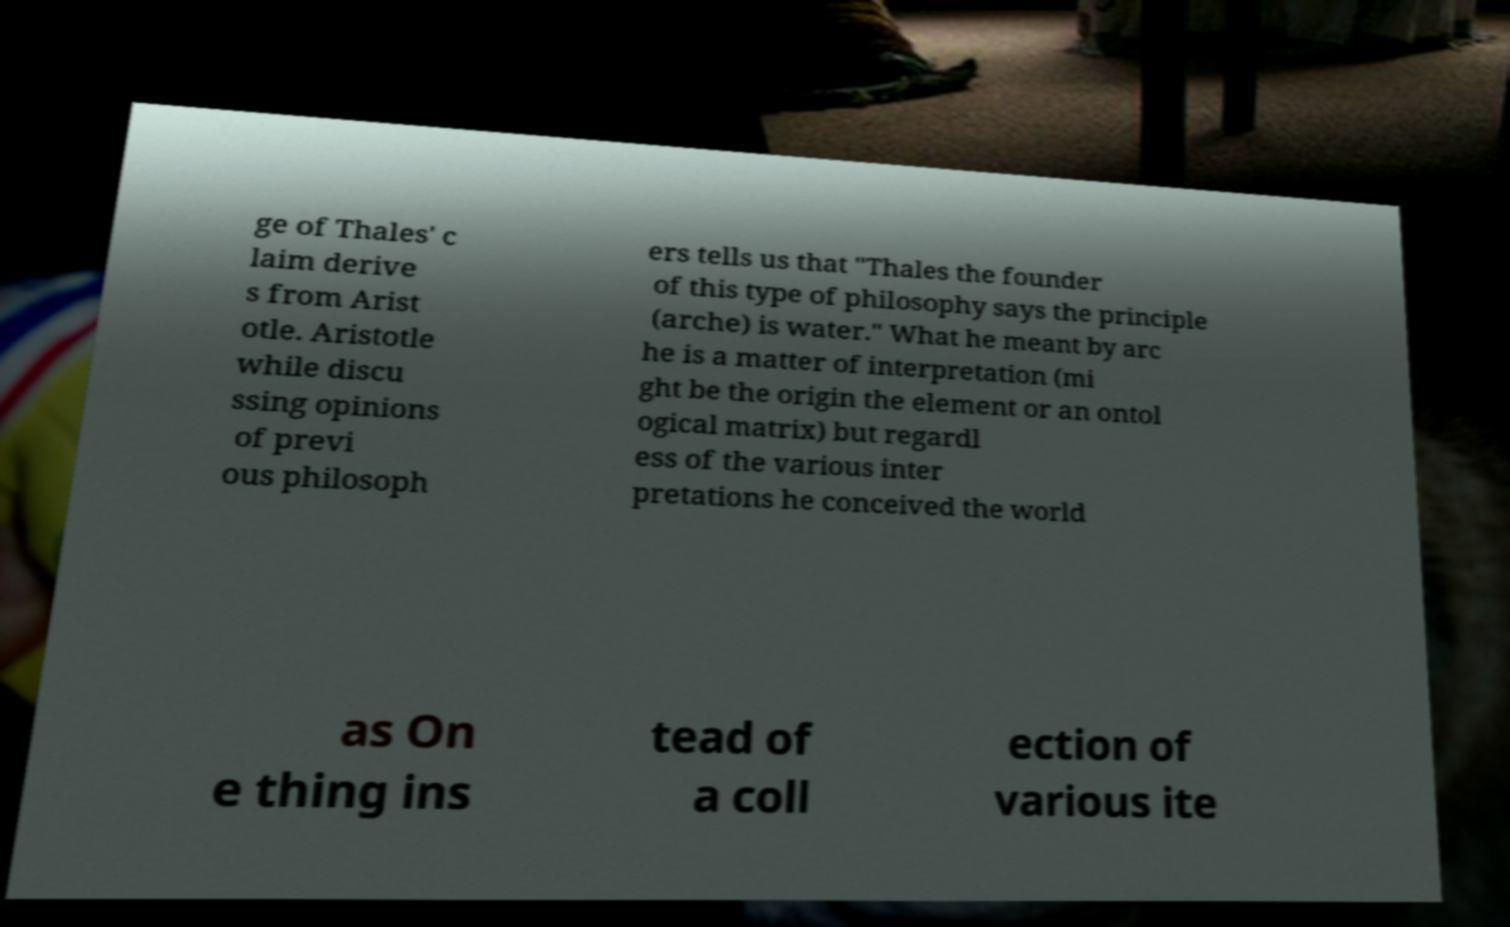I need the written content from this picture converted into text. Can you do that? ge of Thales' c laim derive s from Arist otle. Aristotle while discu ssing opinions of previ ous philosoph ers tells us that "Thales the founder of this type of philosophy says the principle (arche) is water." What he meant by arc he is a matter of interpretation (mi ght be the origin the element or an ontol ogical matrix) but regardl ess of the various inter pretations he conceived the world as On e thing ins tead of a coll ection of various ite 